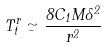<formula> <loc_0><loc_0><loc_500><loc_500>T ^ { r } _ { t } \simeq \frac { 8 C _ { 1 } M \Lambda ^ { 2 } } { r ^ { 2 } }</formula> 